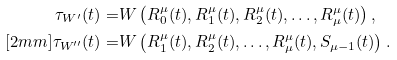Convert formula to latex. <formula><loc_0><loc_0><loc_500><loc_500>\tau _ { W ^ { \prime } } ( t ) = & W \left ( R _ { 0 } ^ { \mu } ( t ) , R _ { 1 } ^ { \mu } ( t ) , R _ { 2 } ^ { \mu } ( t ) , \dots , R _ { \mu } ^ { \mu } ( t ) \right ) , \\ [ 2 m m ] \tau _ { W ^ { \prime \prime } } ( t ) = & W \left ( R _ { 1 } ^ { \mu } ( t ) , R _ { 2 } ^ { \mu } ( t ) , \dots , R _ { \mu } ^ { \mu } ( t ) , S _ { \mu - 1 } ( t ) \right ) .</formula> 